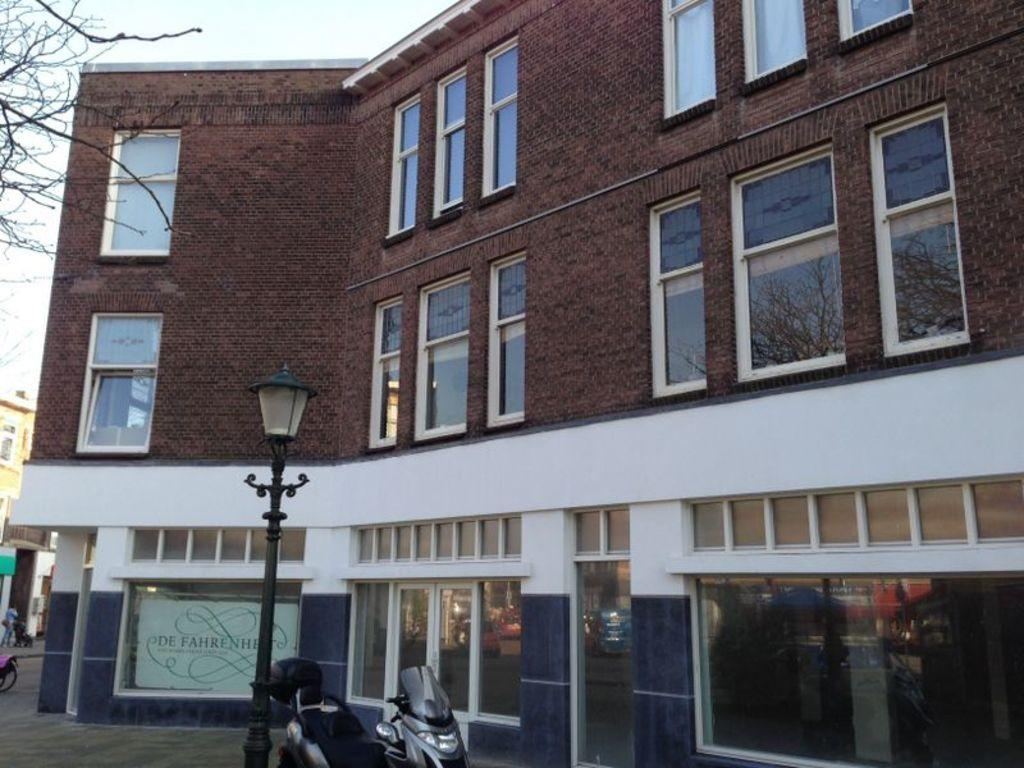What type of structures can be seen in the image? There are buildings in the image. What architectural features are visible on the buildings? Windows are visible in the image. What natural element is present in the image? Branches of a tree are present in the image. What type of object can be seen supporting something else in the image? There is a pole in the image. What artificial light source is visible in the image? A light is visible in the image. What mode of transportation is present in the image? A vehicle is present in the image. What type of sign or notice is present in the image? There is a board in the image. What information is displayed on the board? Something is written on the board. Where is the stamp located in the image? There is no stamp present in the image. What type of breakfast food is being served in the image? There is no breakfast food, such as oatmeal, present in the image. 